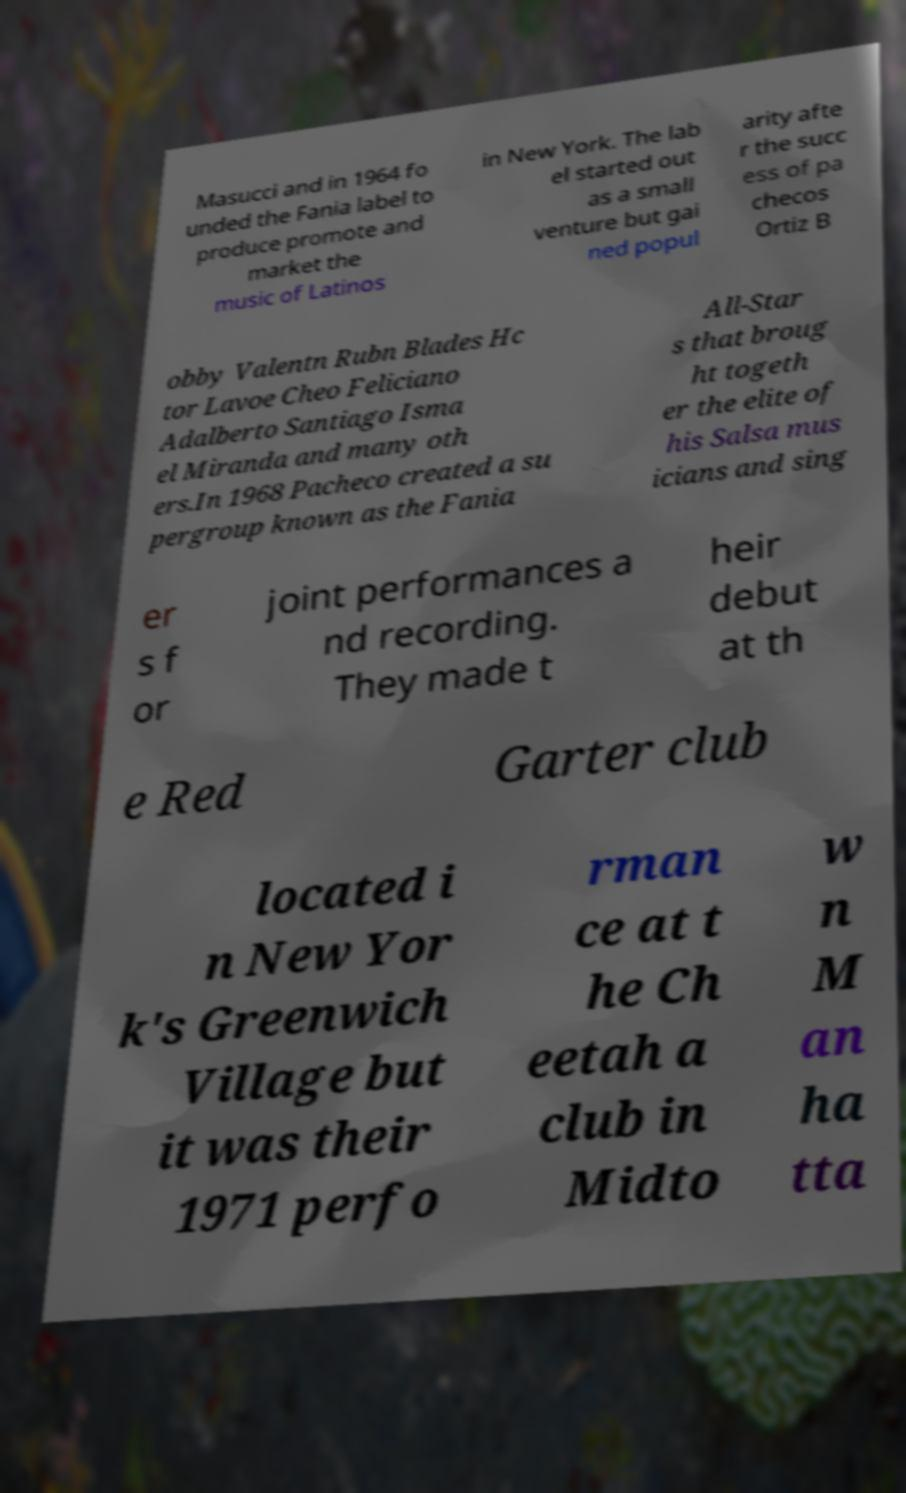What messages or text are displayed in this image? I need them in a readable, typed format. Masucci and in 1964 fo unded the Fania label to produce promote and market the music of Latinos in New York. The lab el started out as a small venture but gai ned popul arity afte r the succ ess of pa checos Ortiz B obby Valentn Rubn Blades Hc tor Lavoe Cheo Feliciano Adalberto Santiago Isma el Miranda and many oth ers.In 1968 Pacheco created a su pergroup known as the Fania All-Star s that broug ht togeth er the elite of his Salsa mus icians and sing er s f or joint performances a nd recording. They made t heir debut at th e Red Garter club located i n New Yor k's Greenwich Village but it was their 1971 perfo rman ce at t he Ch eetah a club in Midto w n M an ha tta 